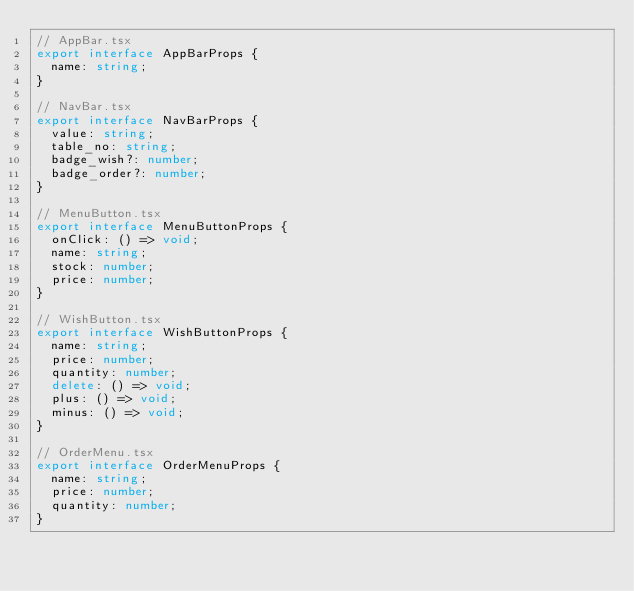Convert code to text. <code><loc_0><loc_0><loc_500><loc_500><_TypeScript_>// AppBar.tsx
export interface AppBarProps {
  name: string;
}

// NavBar.tsx
export interface NavBarProps {
  value: string;
  table_no: string;
  badge_wish?: number;
  badge_order?: number;
}

// MenuButton.tsx
export interface MenuButtonProps {
  onClick: () => void;
  name: string;
  stock: number;
  price: number;
}

// WishButton.tsx
export interface WishButtonProps {
  name: string;
  price: number;
  quantity: number;
  delete: () => void;
  plus: () => void;
  minus: () => void;
}

// OrderMenu.tsx
export interface OrderMenuProps {
  name: string;
  price: number;
  quantity: number;
}
</code> 